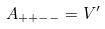<formula> <loc_0><loc_0><loc_500><loc_500>A _ { + + - - } = V ^ { \prime }</formula> 